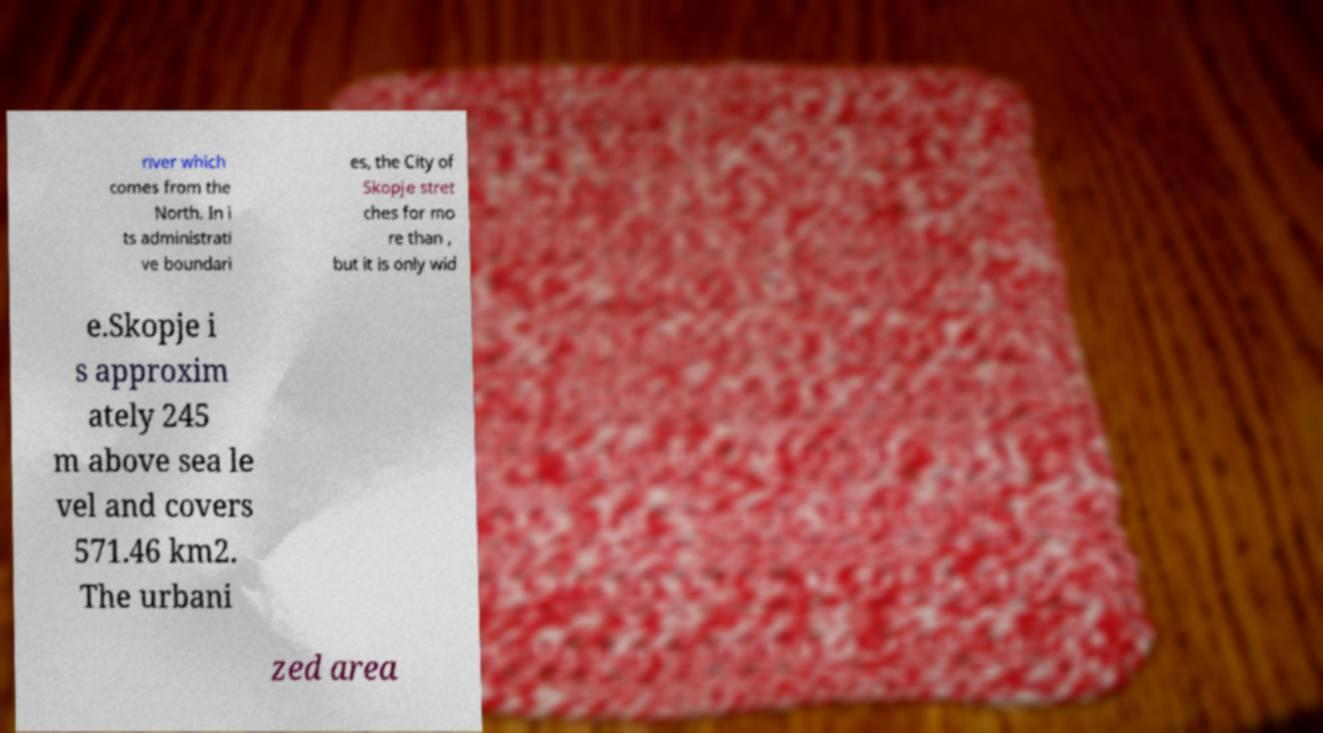Can you accurately transcribe the text from the provided image for me? river which comes from the North. In i ts administrati ve boundari es, the City of Skopje stret ches for mo re than , but it is only wid e.Skopje i s approxim ately 245 m above sea le vel and covers 571.46 km2. The urbani zed area 